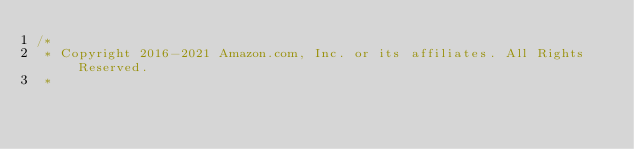<code> <loc_0><loc_0><loc_500><loc_500><_Java_>/*
 * Copyright 2016-2021 Amazon.com, Inc. or its affiliates. All Rights Reserved.
 * </code> 